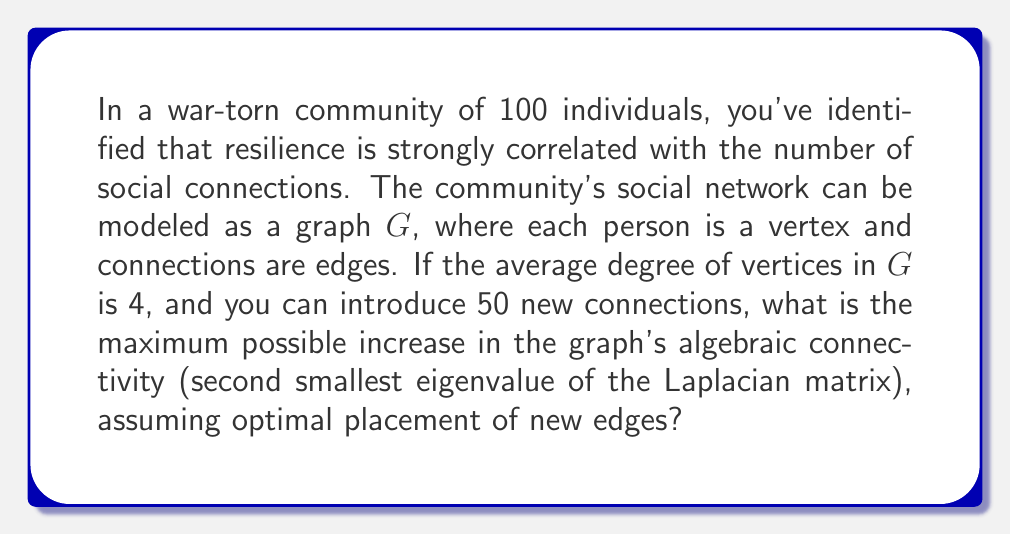Can you answer this question? Let's approach this step-by-step:

1) First, we need to understand the initial state of the graph:
   - Number of vertices: $n = 100$
   - Average degree: $d_{avg} = 4$
   - Total number of edges: $|E| = \frac{nd_{avg}}{2} = \frac{100 \cdot 4}{2} = 200$

2) The Laplacian matrix $L$ of a graph is defined as $L = D - A$, where $D$ is the degree matrix and $A$ is the adjacency matrix.

3) The algebraic connectivity is the second smallest eigenvalue of $L$, denoted as $\lambda_2(L)$.

4) For a connected graph, an upper bound for $\lambda_2(L)$ is given by:

   $$\lambda_2(L) \leq \frac{n}{n-1} \cdot \frac{2|E|}{n}$$

5) Initially, this upper bound is:

   $$\lambda_2(L) \leq \frac{100}{99} \cdot \frac{2 \cdot 200}{100} = \frac{400}{99} \approx 4.04$$

6) After adding 50 new edges, the new upper bound becomes:

   $$\lambda_2(L_{new}) \leq \frac{100}{99} \cdot \frac{2 \cdot 250}{100} = \frac{500}{99} \approx 5.05$$

7) The maximum possible increase in algebraic connectivity is the difference between these upper bounds:

   $$\Delta\lambda_2 \leq \frac{500}{99} - \frac{400}{99} = \frac{100}{99} \approx 1.01$$

Note that this is an upper bound, and the actual increase may be smaller depending on the specific structure of the network and placement of new edges.
Answer: $\frac{100}{99}$ 